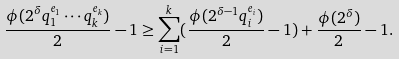Convert formula to latex. <formula><loc_0><loc_0><loc_500><loc_500>\frac { \phi ( 2 ^ { \delta } q _ { 1 } ^ { e _ { 1 } } \cdots q _ { k } ^ { e _ { k } } ) } 2 - 1 \geq \sum _ { i = 1 } ^ { k } ( \frac { \phi ( 2 ^ { \delta - 1 } q _ { i } ^ { e _ { i } } ) } 2 - 1 ) + \frac { \phi ( 2 ^ { \delta } ) } 2 - 1 .</formula> 